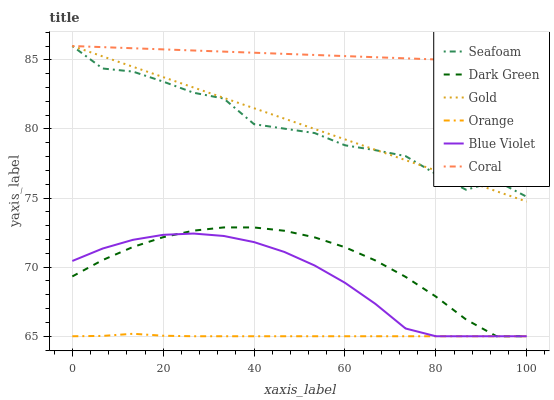Does Orange have the minimum area under the curve?
Answer yes or no. Yes. Does Coral have the maximum area under the curve?
Answer yes or no. Yes. Does Seafoam have the minimum area under the curve?
Answer yes or no. No. Does Seafoam have the maximum area under the curve?
Answer yes or no. No. Is Gold the smoothest?
Answer yes or no. Yes. Is Seafoam the roughest?
Answer yes or no. Yes. Is Coral the smoothest?
Answer yes or no. No. Is Coral the roughest?
Answer yes or no. No. Does Orange have the lowest value?
Answer yes or no. Yes. Does Seafoam have the lowest value?
Answer yes or no. No. Does Seafoam have the highest value?
Answer yes or no. Yes. Does Orange have the highest value?
Answer yes or no. No. Is Blue Violet less than Seafoam?
Answer yes or no. Yes. Is Seafoam greater than Orange?
Answer yes or no. Yes. Does Seafoam intersect Gold?
Answer yes or no. Yes. Is Seafoam less than Gold?
Answer yes or no. No. Is Seafoam greater than Gold?
Answer yes or no. No. Does Blue Violet intersect Seafoam?
Answer yes or no. No. 